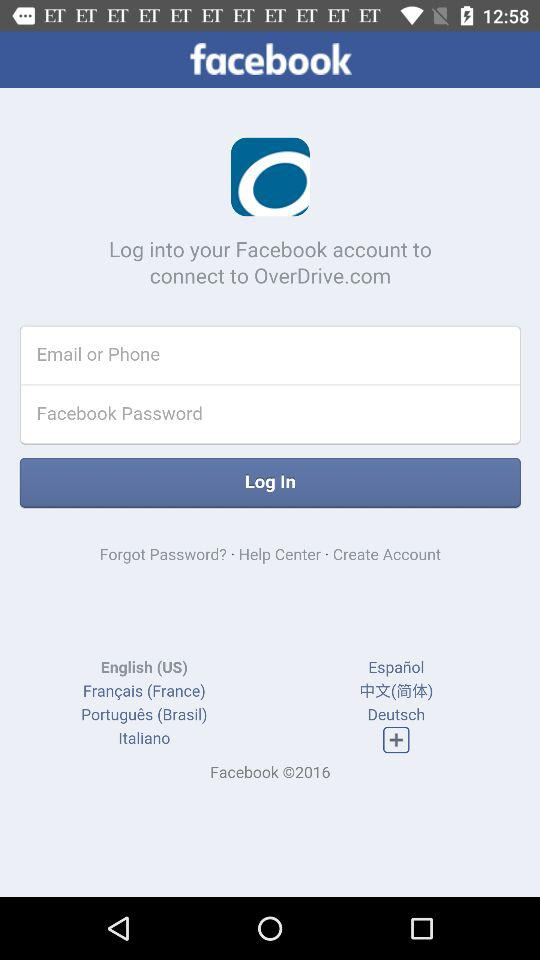How many language options are given?
When the provided information is insufficient, respond with <no answer>. <no answer> 